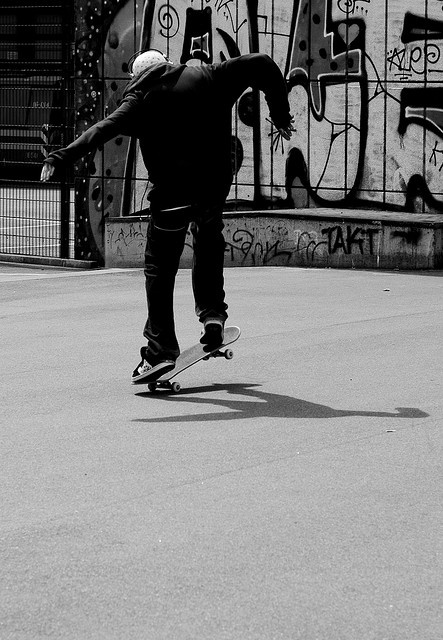Describe the objects in this image and their specific colors. I can see people in black, gray, darkgray, and lightgray tones and skateboard in black, darkgray, gray, and lightgray tones in this image. 